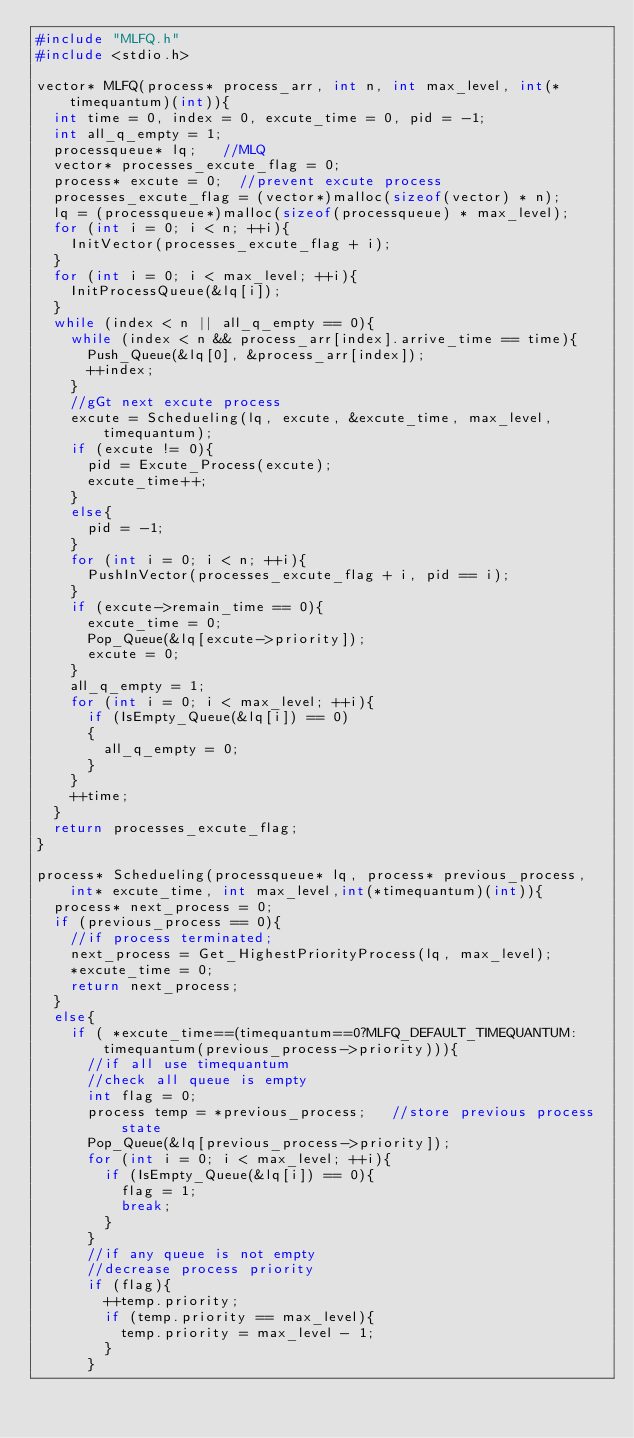<code> <loc_0><loc_0><loc_500><loc_500><_C_>#include "MLFQ.h"
#include <stdio.h>

vector* MLFQ(process* process_arr, int n, int max_level, int(*timequantum)(int)){
	int time = 0, index = 0, excute_time = 0, pid = -1;
	int all_q_empty = 1;
	processqueue* lq;		//MLQ
	vector* processes_excute_flag = 0;
	process* excute = 0;	//prevent excute process 
	processes_excute_flag = (vector*)malloc(sizeof(vector) * n);
	lq = (processqueue*)malloc(sizeof(processqueue) * max_level);
	for (int i = 0; i < n; ++i){
		InitVector(processes_excute_flag + i);
	}
	for (int i = 0; i < max_level; ++i){
		InitProcessQueue(&lq[i]);
	}
	while (index < n || all_q_empty == 0){
		while (index < n && process_arr[index].arrive_time == time){
			Push_Queue(&lq[0], &process_arr[index]);
			++index;
		}
		//gGt next excute process 
		excute = Schedueling(lq, excute, &excute_time, max_level, timequantum);
		if (excute != 0){
			pid = Excute_Process(excute);
			excute_time++;
		}
		else{
			pid = -1;
		}
		for (int i = 0; i < n; ++i){
			PushInVector(processes_excute_flag + i, pid == i);
		}
		if (excute->remain_time == 0){
			excute_time = 0;
			Pop_Queue(&lq[excute->priority]);
			excute = 0;
		}
		all_q_empty = 1;
		for (int i = 0; i < max_level; ++i){
			if (IsEmpty_Queue(&lq[i]) == 0)
			{
				all_q_empty = 0;
			}
		}
		++time;
	}
	return processes_excute_flag;
}

process* Schedueling(processqueue* lq, process* previous_process, int* excute_time, int max_level,int(*timequantum)(int)){
	process* next_process = 0;
	if (previous_process == 0){
		//if process terminated;
		next_process = Get_HighestPriorityProcess(lq, max_level); 
		*excute_time = 0;
		return next_process;
	}
	else{
		if ( *excute_time==(timequantum==0?MLFQ_DEFAULT_TIMEQUANTUM:timequantum(previous_process->priority))){
			//if all use timequantum
			//check all queue is empty
			int flag = 0;
			process temp = *previous_process;		//store previous process state
			Pop_Queue(&lq[previous_process->priority]);
			for (int i = 0; i < max_level; ++i){
				if (IsEmpty_Queue(&lq[i]) == 0){
					flag = 1;
					break;
				}
			}
			//if any queue is not empty
			//decrease process priority
			if (flag){
				++temp.priority;
				if (temp.priority == max_level){
					temp.priority = max_level - 1;
				}
			}</code> 